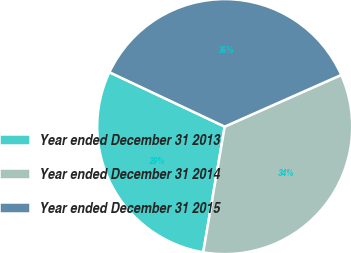<chart> <loc_0><loc_0><loc_500><loc_500><pie_chart><fcel>Year ended December 31 2013<fcel>Year ended December 31 2014<fcel>Year ended December 31 2015<nl><fcel>29.32%<fcel>34.34%<fcel>36.34%<nl></chart> 